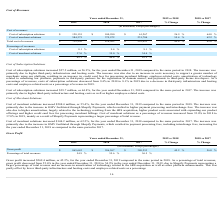From Shopify's financial document, Which 2 financial items does cost of revenues consist of? The document shows two values: Cost of subscription solutions and Cost of merchant solutions. From the document: "Cost of subscription solutions $ 128,155 $ 100,990 $ 61,267 26.9 % 64.8 % Cost of merchant solutions 584,375 375,972 231,784 55.4 % 62.2 %..." Also, Which financial years' information does the table show (in chronological order)? The document contains multiple relevant values: 2017, 2018, 2019. From the document: "Years ended December 31, 2019 vs 2018 2018 vs 2017 Years ended December 31, 2019 vs 2018 2018 vs 2017 Years ended December 31, 2019 vs 2018 2018 vs 20..." Also, What is the 2019 year ended cost of subscription solutions? According to the financial document, $ 128,155 (in thousands). The relevant text states: "Cost of subscription solutions $ 128,155 $ 100,990 $ 61,267 26.9 % 64.8 %..." Additionally, Which year had the highest total cost of revenues? According to the financial document, 2019. The relevant text states: "Years ended December 31, 2019 vs 2018 2018 vs 2017..." Additionally, Between year ended 2018 and 2019, which year had a higher cost of merchant solutions? According to the financial document, 2019. The relevant text states: "Years ended December 31, 2019 vs 2018 2018 vs 2017..." Also, can you calculate: What's the total revenue in 2019? Based on the calculation: 712,530/45.1 %, the result is 1579889.14 (in thousands). This is based on the information: "Total cost of revenues $ 712,530 $ 476,962 $ 293,051 49.4 % 62.8 % 45.1 % 44.4 % 43.5 %..." The key data points involved are: 45.1, 712,530. 